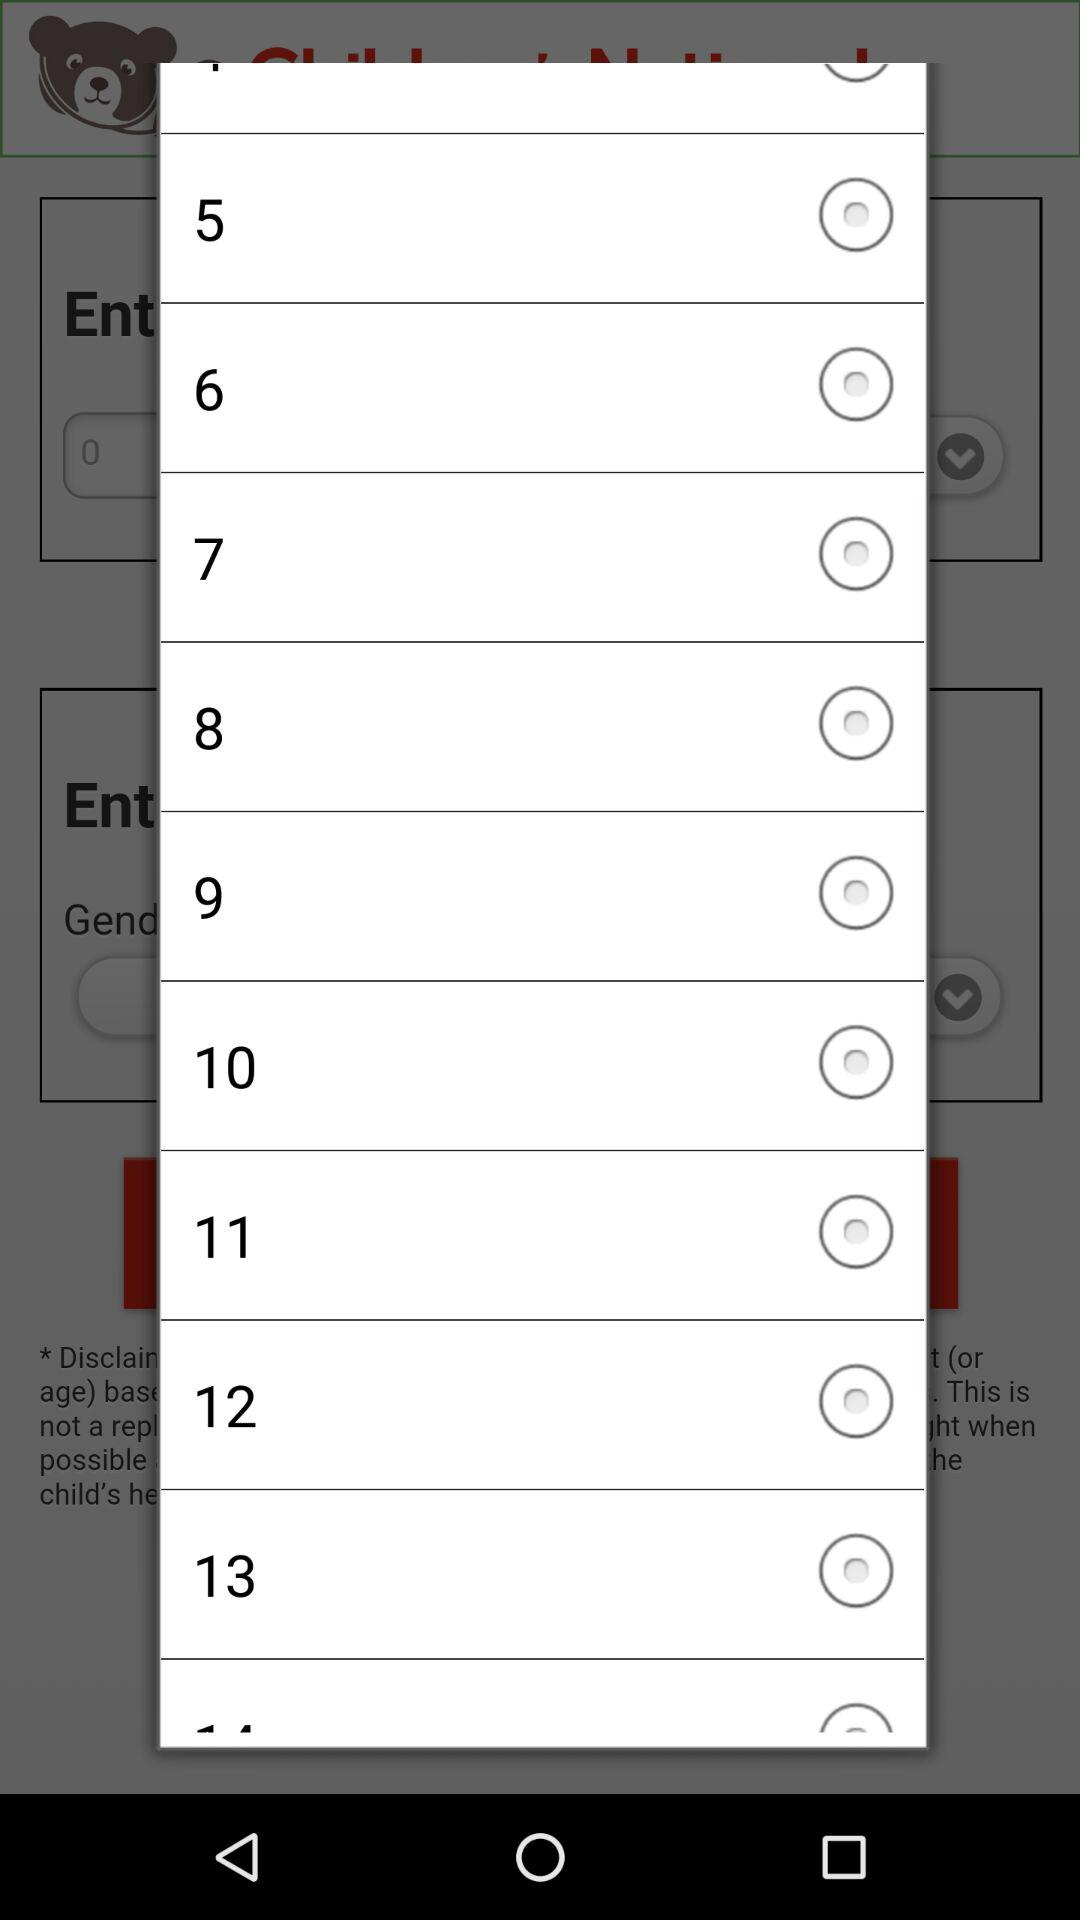Is "8" selected or not? "8" is not selected. 